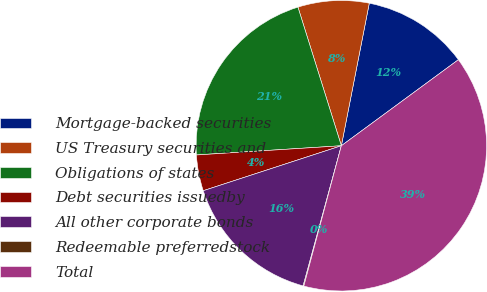Convert chart to OTSL. <chart><loc_0><loc_0><loc_500><loc_500><pie_chart><fcel>Mortgage-backed securities<fcel>US Treasury securities and<fcel>Obligations of states<fcel>Debt securities issuedby<fcel>All other corporate bonds<fcel>Redeemable preferredstock<fcel>Total<nl><fcel>11.83%<fcel>7.91%<fcel>21.18%<fcel>4.0%<fcel>15.75%<fcel>0.08%<fcel>39.25%<nl></chart> 